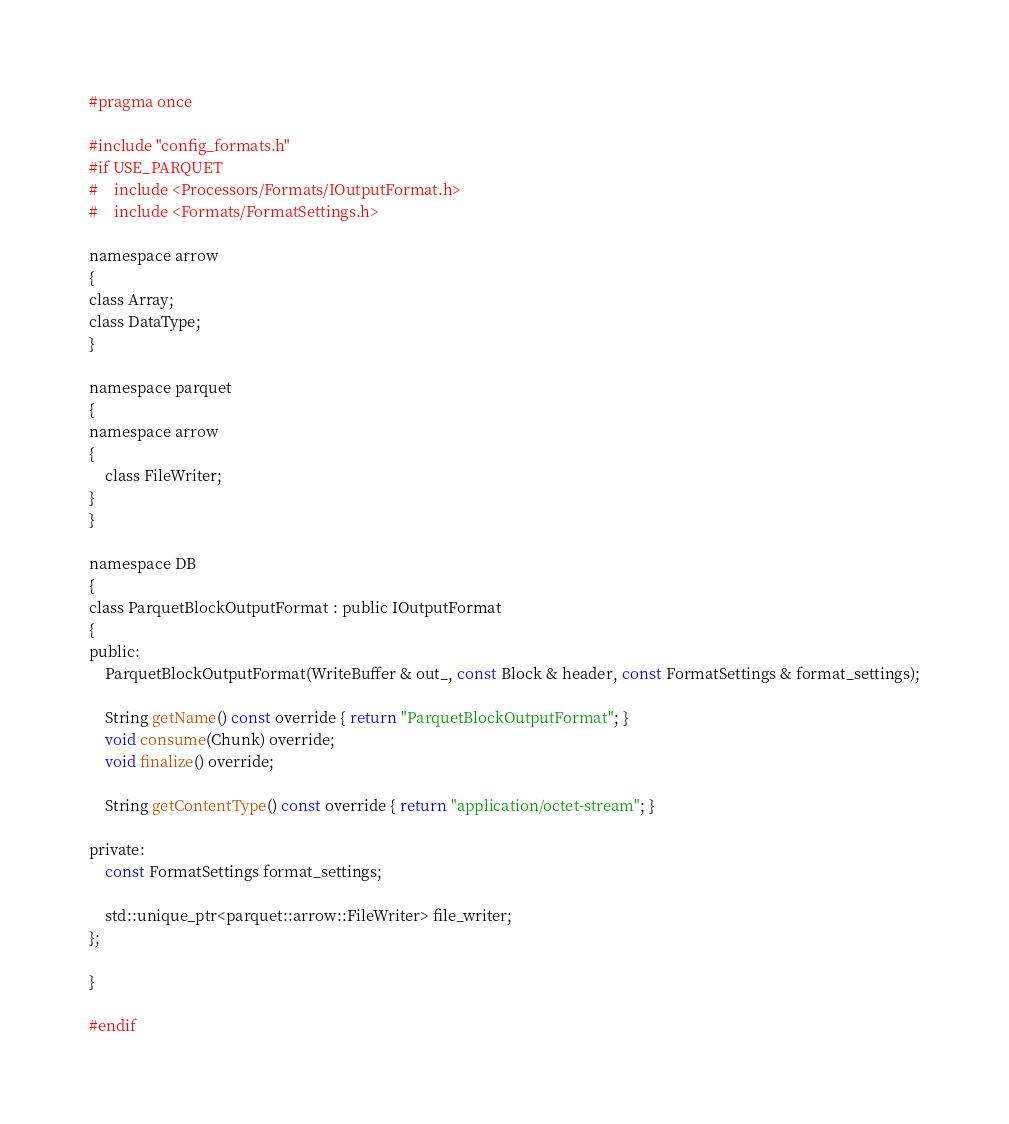Convert code to text. <code><loc_0><loc_0><loc_500><loc_500><_C_>#pragma once

#include "config_formats.h"
#if USE_PARQUET
#    include <Processors/Formats/IOutputFormat.h>
#    include <Formats/FormatSettings.h>

namespace arrow
{
class Array;
class DataType;
}

namespace parquet
{
namespace arrow
{
    class FileWriter;
}
}

namespace DB
{
class ParquetBlockOutputFormat : public IOutputFormat
{
public:
    ParquetBlockOutputFormat(WriteBuffer & out_, const Block & header, const FormatSettings & format_settings);

    String getName() const override { return "ParquetBlockOutputFormat"; }
    void consume(Chunk) override;
    void finalize() override;

    String getContentType() const override { return "application/octet-stream"; }

private:
    const FormatSettings format_settings;

    std::unique_ptr<parquet::arrow::FileWriter> file_writer;
};

}

#endif
</code> 